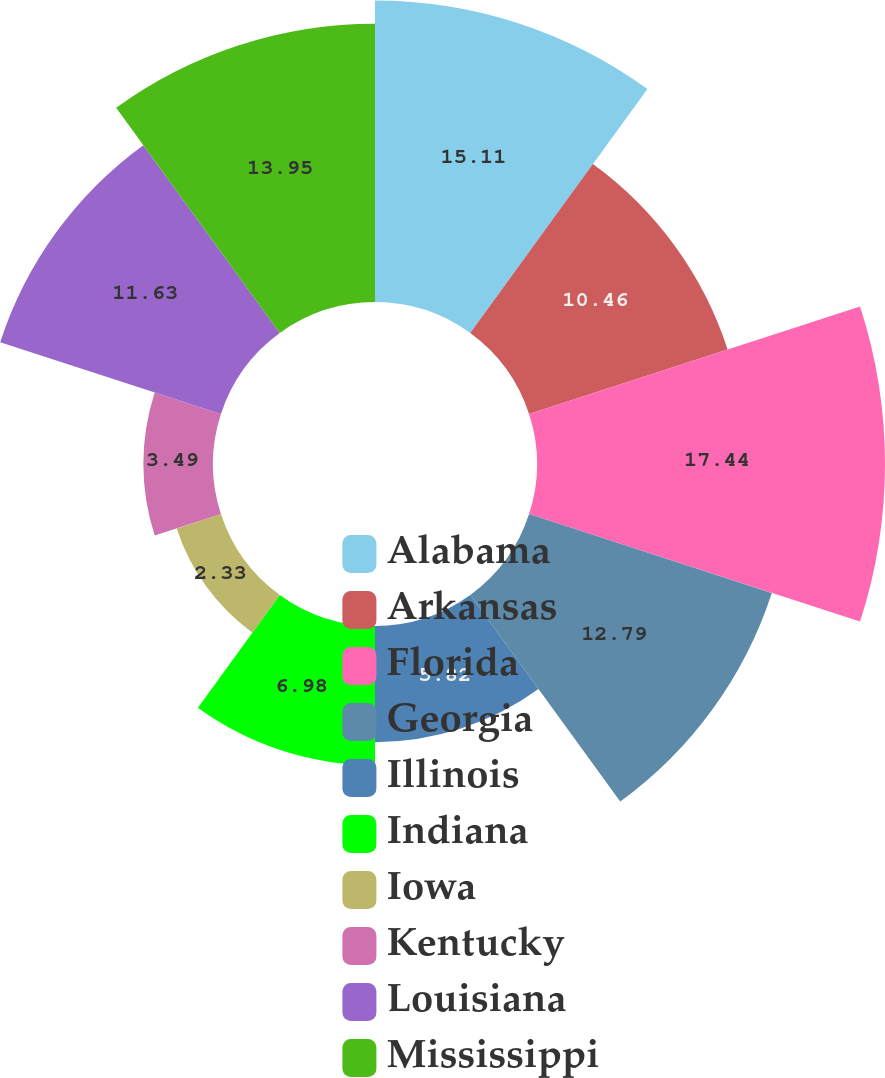<chart> <loc_0><loc_0><loc_500><loc_500><pie_chart><fcel>Alabama<fcel>Arkansas<fcel>Florida<fcel>Georgia<fcel>Illinois<fcel>Indiana<fcel>Iowa<fcel>Kentucky<fcel>Louisiana<fcel>Mississippi<nl><fcel>15.11%<fcel>10.46%<fcel>17.44%<fcel>12.79%<fcel>5.82%<fcel>6.98%<fcel>2.33%<fcel>3.49%<fcel>11.63%<fcel>13.95%<nl></chart> 